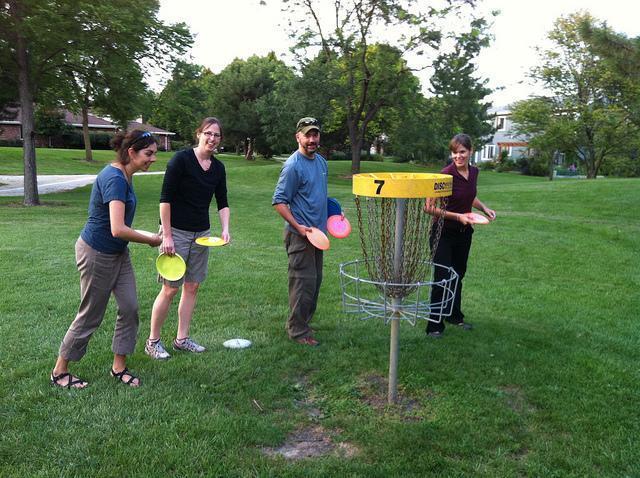How many people are in the photo?
Give a very brief answer. 4. How many laptops are in this picture?
Give a very brief answer. 0. 